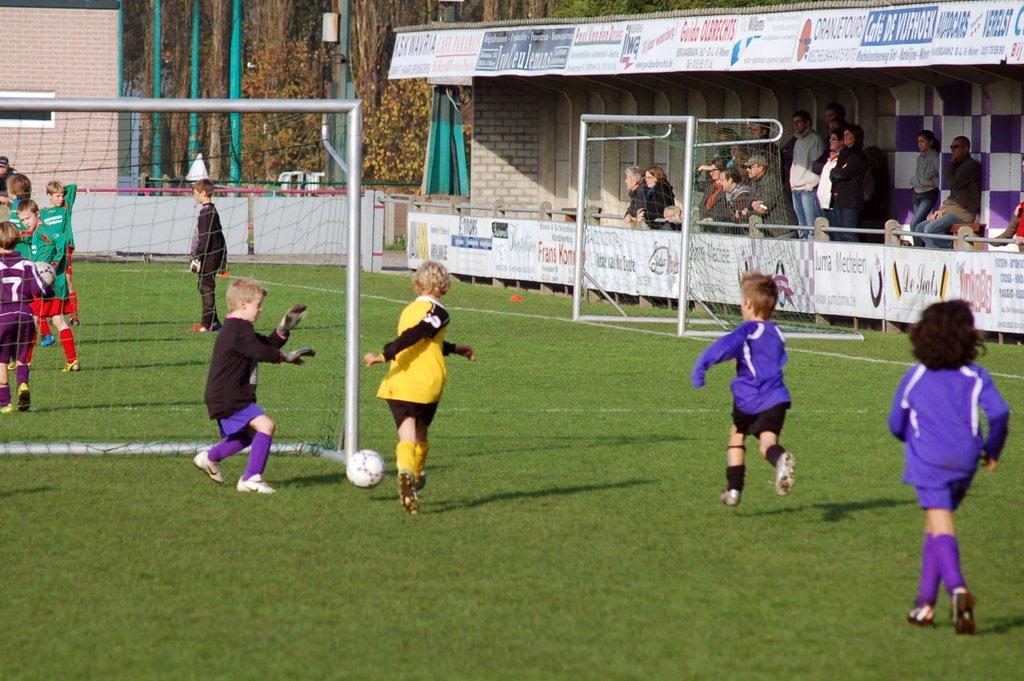What is the player on the lefts number?
Offer a terse response. 7. 